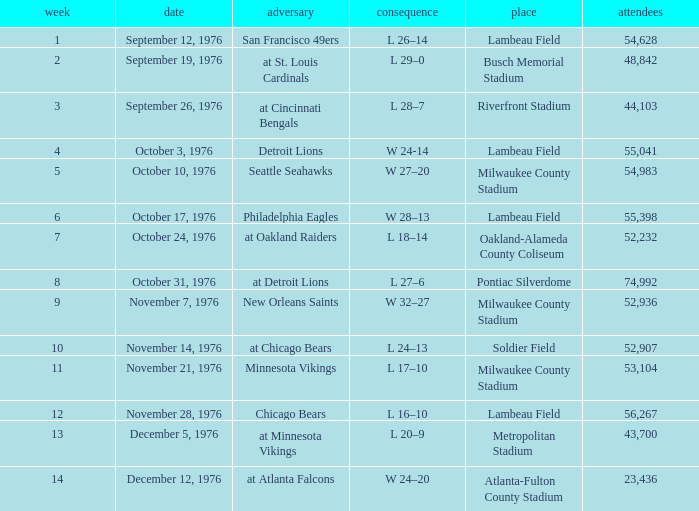What is the lowest week number where they played against the Detroit Lions? 4.0. 